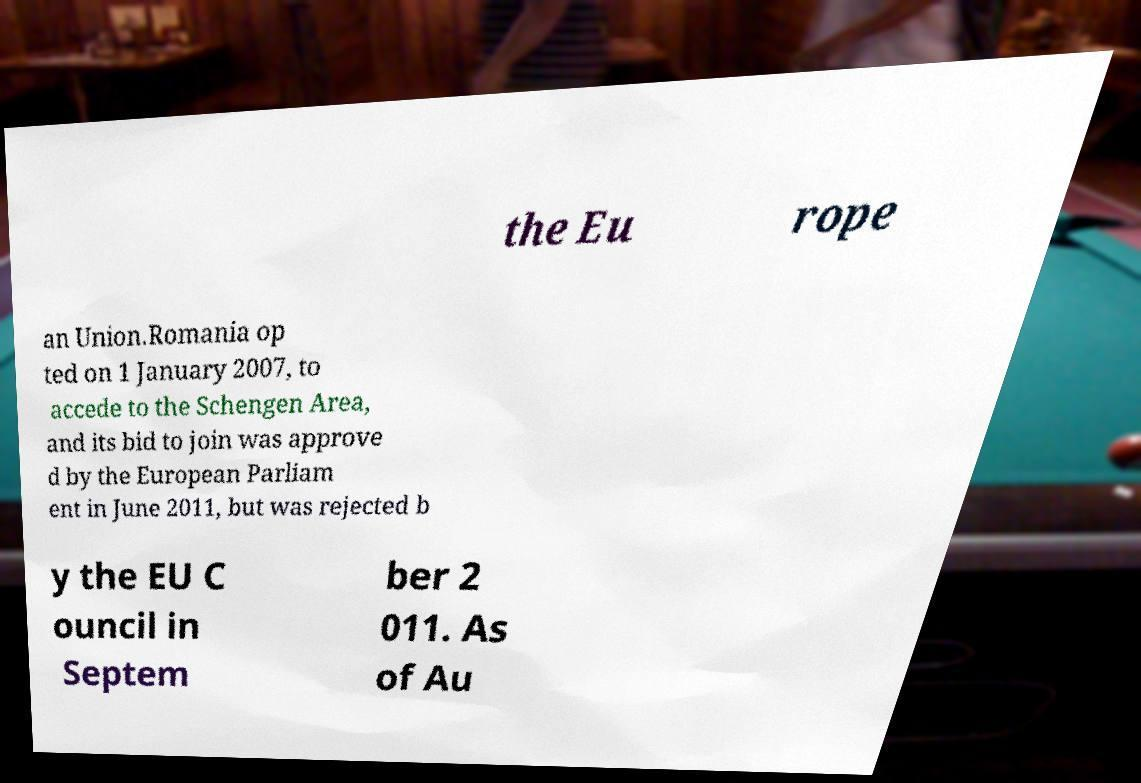There's text embedded in this image that I need extracted. Can you transcribe it verbatim? the Eu rope an Union.Romania op ted on 1 January 2007, to accede to the Schengen Area, and its bid to join was approve d by the European Parliam ent in June 2011, but was rejected b y the EU C ouncil in Septem ber 2 011. As of Au 